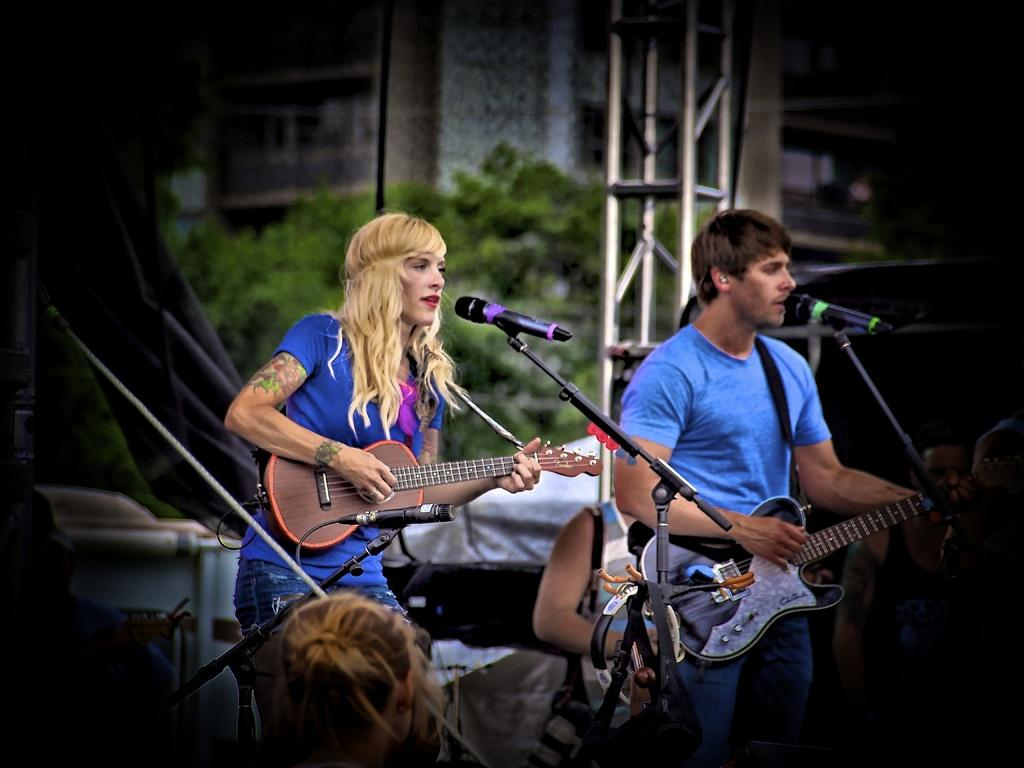What are the people in the image doing? The people in the image are standing and holding guitars. What objects are in front of the people? There are microphones in front of the people. What can be seen in the background of the image? There is a tree and a building in the background of the image. What type of branch is the agreement signed on in the image? There is no branch or agreement present in the image. How many seats are visible in the image? There are no seats visible in the image. 